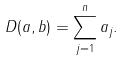<formula> <loc_0><loc_0><loc_500><loc_500>D ( a , b ) = \sum _ { j = 1 } ^ { n } a _ { j } .</formula> 